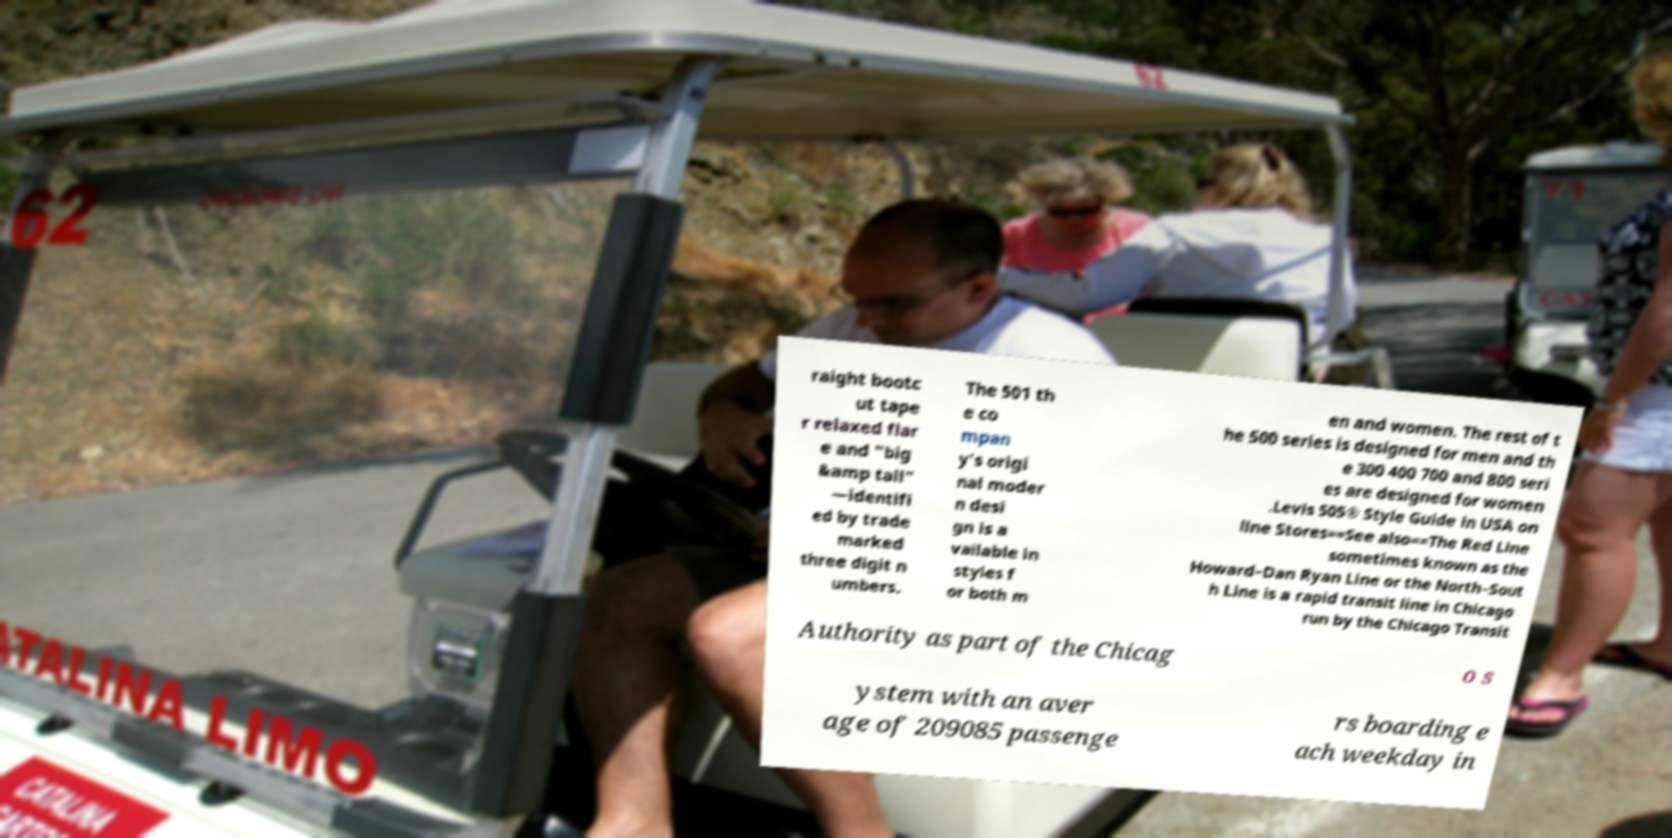Could you assist in decoding the text presented in this image and type it out clearly? raight bootc ut tape r relaxed flar e and "big &amp tall" —identifi ed by trade marked three digit n umbers. The 501 th e co mpan y's origi nal moder n desi gn is a vailable in styles f or both m en and women. The rest of t he 500 series is designed for men and th e 300 400 700 and 800 seri es are designed for women .Levis 505® Style Guide in USA on line Stores==See also==The Red Line sometimes known as the Howard–Dan Ryan Line or the North–Sout h Line is a rapid transit line in Chicago run by the Chicago Transit Authority as part of the Chicag o s ystem with an aver age of 209085 passenge rs boarding e ach weekday in 